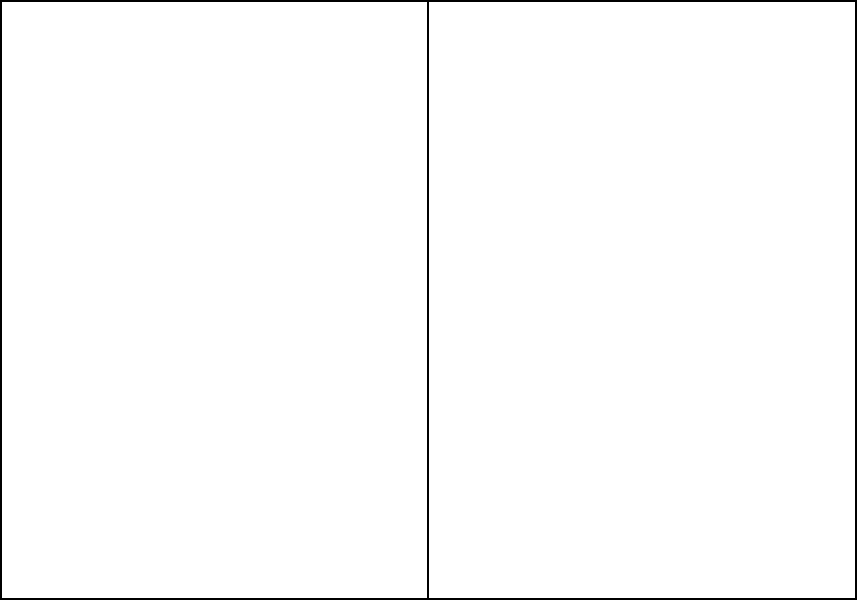Based on the diagram showing Jurgen Klinsmann's preferred formation, which tactical setup does this average player positioning most closely resemble? To determine the tactical setup from the average player positions, let's analyze the diagram step-by-step:

1. We can see 6 outfield players represented by red dots on the field.
2. The formation appears symmetrical, with players spread across the field.
3. There is one player (labeled GK) positioned deep, likely the goalkeeper.
4. Two players (labeled CB) are positioned slightly ahead of the goalkeeper, forming a defensive line.
5. Two players (labeled CM) are positioned in the middle of the field, forming a midfield line.
6. One player (labeled ST) is positioned furthest forward, likely the striker.

This positioning of players closely resembles a 4-2-3-1 formation, which is a popular modern tactical setup. However, the diagram only shows 6 players (5 outfield players plus a goalkeeper), so we're seeing a simplified version of this formation.

The 4-2-3-1 typically includes:
- 4 defenders (two center-backs shown in the diagram)
- 2 defensive midfielders (shown as CM in the diagram)
- 3 attacking midfielders (not fully represented in this simplified diagram)
- 1 striker (shown as ST in the diagram)

Given the limited number of players shown, this diagram most closely represents a simplified 2-2-1 formation, which is essentially a stripped-down version of the 4-2-3-1, focusing on the spine of the team.
Answer: Simplified 2-2-1 (representation of 4-2-3-1) 